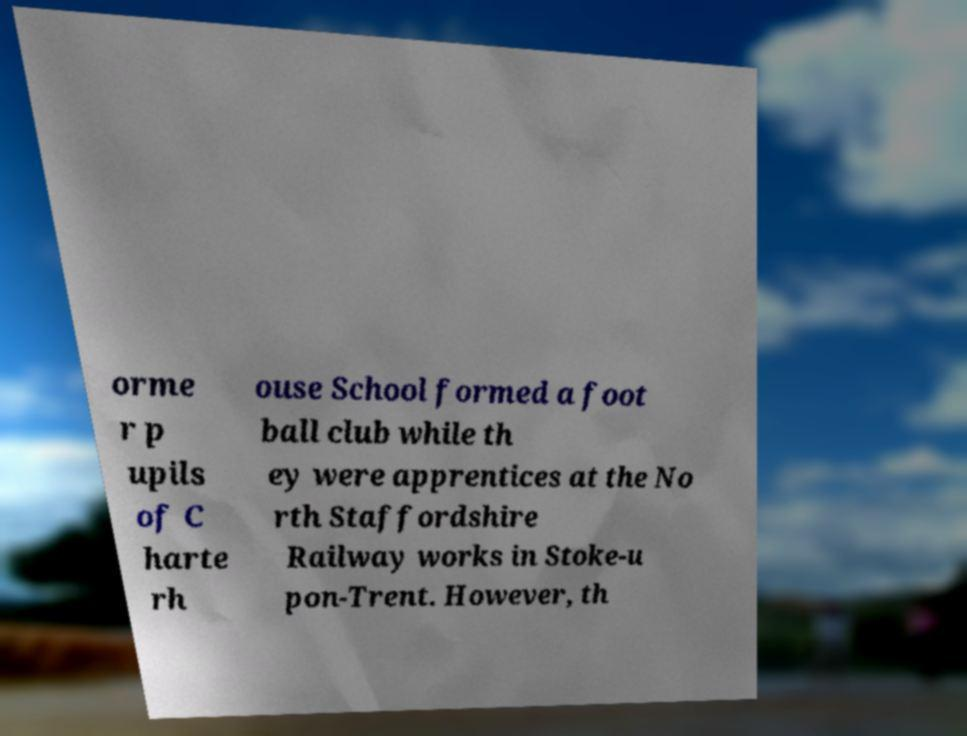Can you accurately transcribe the text from the provided image for me? orme r p upils of C harte rh ouse School formed a foot ball club while th ey were apprentices at the No rth Staffordshire Railway works in Stoke-u pon-Trent. However, th 